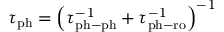<formula> <loc_0><loc_0><loc_500><loc_500>\begin{array} { r } { \tau _ { p h } = \left ( \tau _ { p h - p h } ^ { - 1 } + \tau _ { p h - r o } ^ { - 1 } \right ) ^ { - 1 } } \end{array}</formula> 